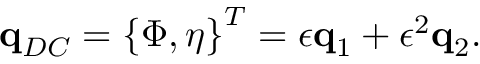Convert formula to latex. <formula><loc_0><loc_0><loc_500><loc_500>q _ { D C } = \left \{ \Phi , \eta \right \} ^ { T } = \epsilon q _ { 1 } + \epsilon ^ { 2 } q _ { 2 } .</formula> 